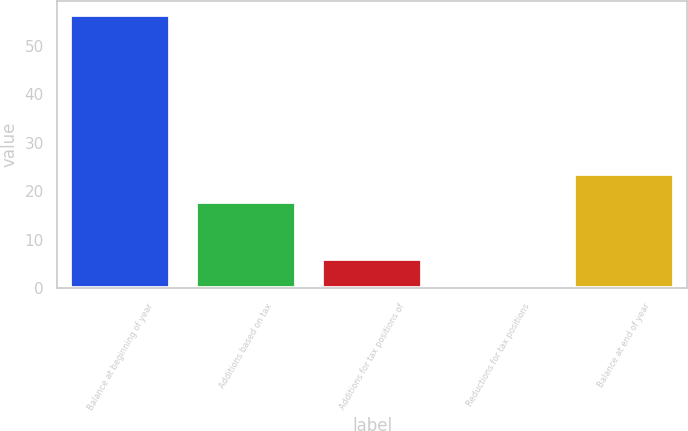<chart> <loc_0><loc_0><loc_500><loc_500><bar_chart><fcel>Balance at beginning of year<fcel>Additions based on tax<fcel>Additions for tax positions of<fcel>Reductions for tax positions<fcel>Balance at end of year<nl><fcel>56.4<fcel>17.9<fcel>6<fcel>0.4<fcel>23.5<nl></chart> 